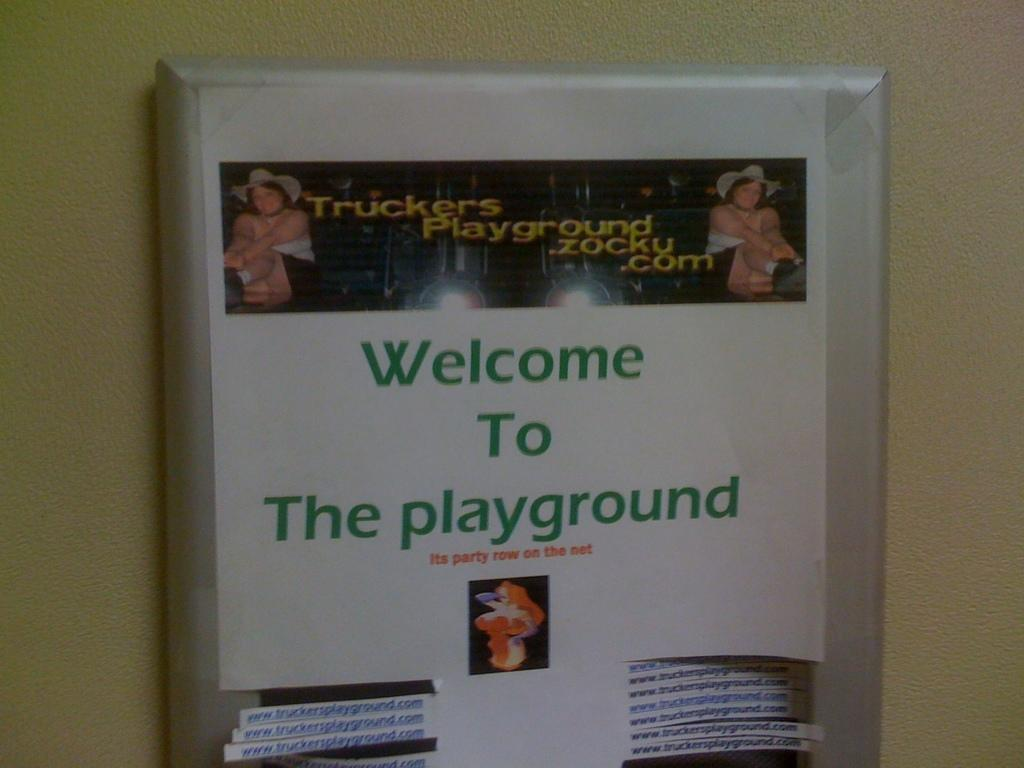Provide a one-sentence caption for the provided image. A sign which reads, "Welcome to The playground" is hanging on a wall. 